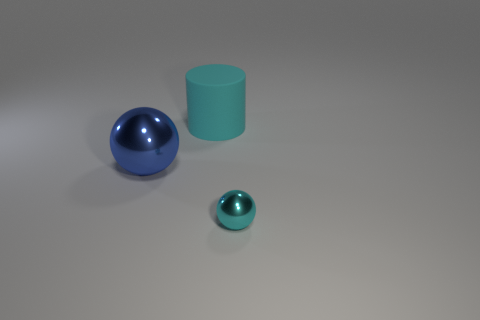Is the cylinder the same color as the small thing?
Your response must be concise. Yes. The blue thing that is the same shape as the cyan metallic thing is what size?
Your response must be concise. Large. There is a tiny thing that is the same color as the matte cylinder; what is it made of?
Ensure brevity in your answer.  Metal. There is a small ball that is made of the same material as the blue object; what color is it?
Ensure brevity in your answer.  Cyan. There is a large blue thing; are there any blue things in front of it?
Offer a terse response. No. The thing that is in front of the large cyan cylinder and left of the cyan metallic sphere is made of what material?
Your answer should be compact. Metal. Are the thing in front of the large ball and the cylinder made of the same material?
Ensure brevity in your answer.  No. What material is the tiny object?
Your answer should be very brief. Metal. How big is the metal object that is in front of the big shiny object?
Your response must be concise. Small. Is there anything else of the same color as the big sphere?
Give a very brief answer. No. 